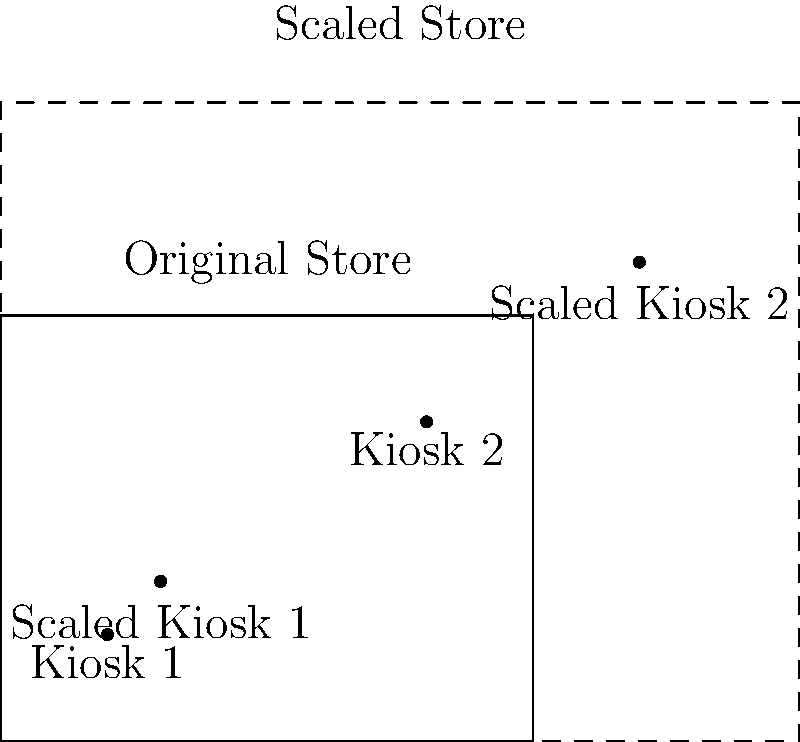You plan to expand your grocery store to accommodate new coupon kiosks. The current store has a rectangular floor plan measuring 10 units by 8 units, with two kiosk locations at coordinates (2,2) and (8,6). If you want to scale up the entire store layout by a factor of 1.5, what will be the new coordinates of the two kiosks in the scaled floor plan? To solve this problem, we need to apply the concept of scaling in transformational geometry. When we scale a figure, all its dimensions and coordinates are multiplied by the scale factor. In this case, the scale factor is 1.5.

Step 1: Identify the original coordinates of the kiosks.
Kiosk 1: (2,2)
Kiosk 2: (8,6)

Step 2: Apply the scaling factor to each coordinate.
For each coordinate (x,y), the new coordinate will be (1.5x, 1.5y).

For Kiosk 1:
New x-coordinate = 1.5 * 2 = 3
New y-coordinate = 1.5 * 2 = 3
New position of Kiosk 1: (3,3)

For Kiosk 2:
New x-coordinate = 1.5 * 8 = 12
New y-coordinate = 1.5 * 6 = 9
New position of Kiosk 2: (12,9)

Step 3: Verify the results.
We can see that the new coordinates maintain the same relative positions in the scaled floor plan, but their absolute positions have increased by a factor of 1.5.
Answer: Kiosk 1: (3,3), Kiosk 2: (12,9) 